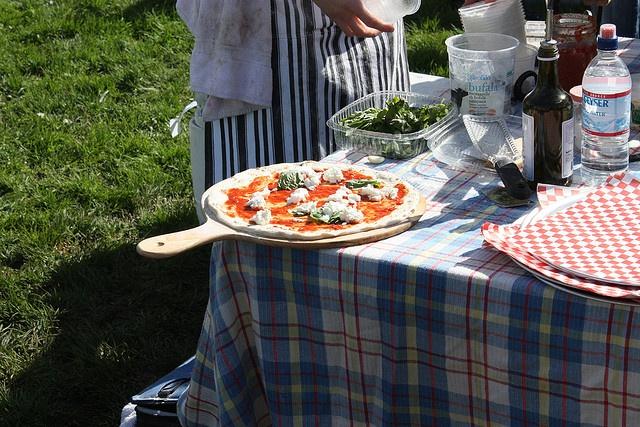Describe the objects in this image and their specific colors. I can see dining table in olive, white, black, darkgray, and gray tones, people in olive, gray, black, and lightgray tones, pizza in olive, ivory, red, tan, and orange tones, bottle in olive, darkgray, lightgray, and gray tones, and bottle in olive, black, darkgray, and gray tones in this image. 